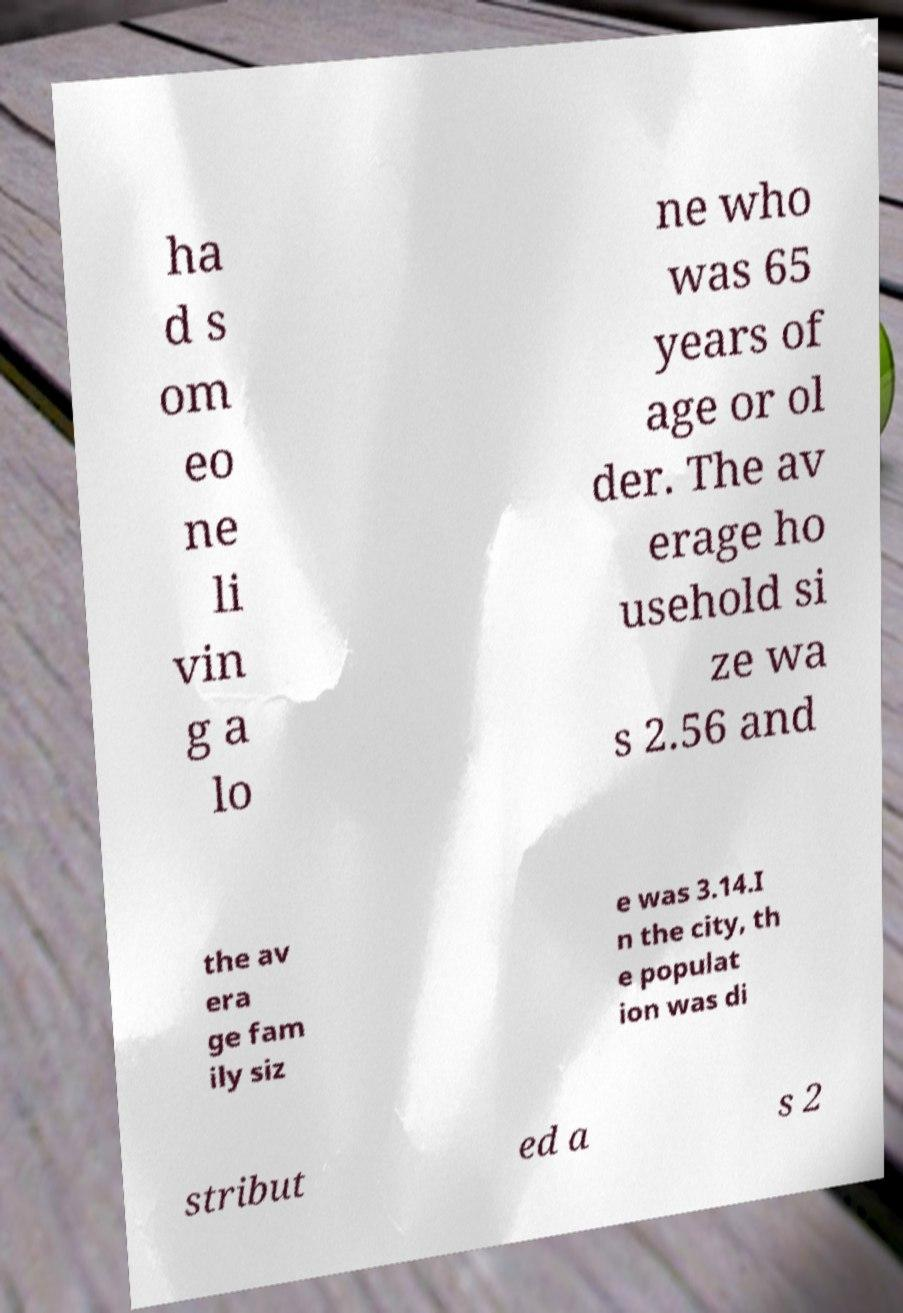Please identify and transcribe the text found in this image. ha d s om eo ne li vin g a lo ne who was 65 years of age or ol der. The av erage ho usehold si ze wa s 2.56 and the av era ge fam ily siz e was 3.14.I n the city, th e populat ion was di stribut ed a s 2 